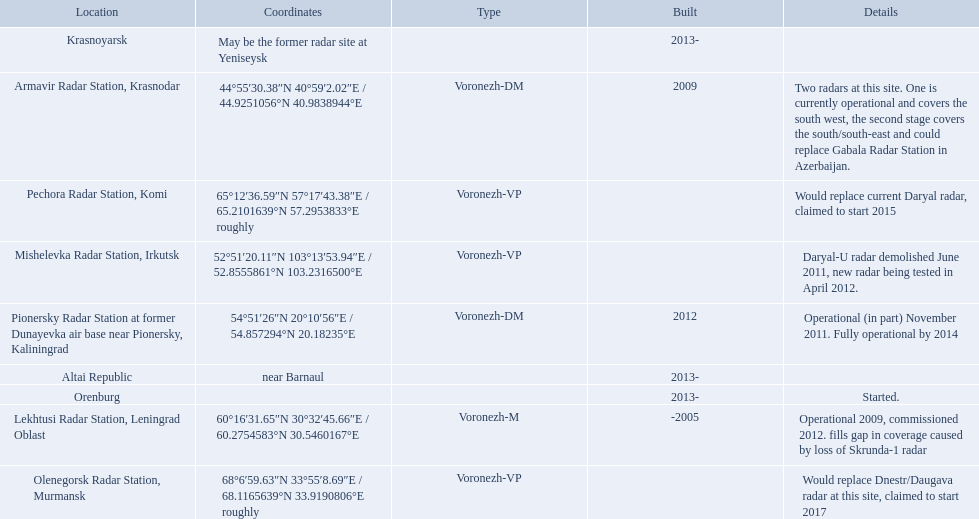What are the list of radar locations? Lekhtusi Radar Station, Leningrad Oblast, Armavir Radar Station, Krasnodar, Pionersky Radar Station at former Dunayevka air base near Pionersky, Kaliningrad, Mishelevka Radar Station, Irkutsk, Pechora Radar Station, Komi, Olenegorsk Radar Station, Murmansk, Krasnoyarsk, Altai Republic, Orenburg. Which of these are claimed to start in 2015? Pechora Radar Station, Komi. 